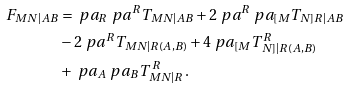Convert formula to latex. <formula><loc_0><loc_0><loc_500><loc_500>F _ { M N | A B } & = \ p a _ { R } \ p a ^ { R } T _ { M N | A B } + 2 \ p a ^ { R } \ p a _ { [ M } T _ { N ] R | A B } \\ & - 2 \ p a ^ { R } T _ { M N | R ( A , B ) } + 4 \ p a _ { [ M } T ^ { R } _ { \, N ] | R ( A , B ) } \\ & + \ p a _ { A } \ p a _ { B } T ^ { \, R } _ { M N | R } \, .</formula> 